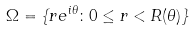<formula> <loc_0><loc_0><loc_500><loc_500>\Omega = \{ r e ^ { i \theta } \colon 0 \leq r < R ( \theta ) \}</formula> 